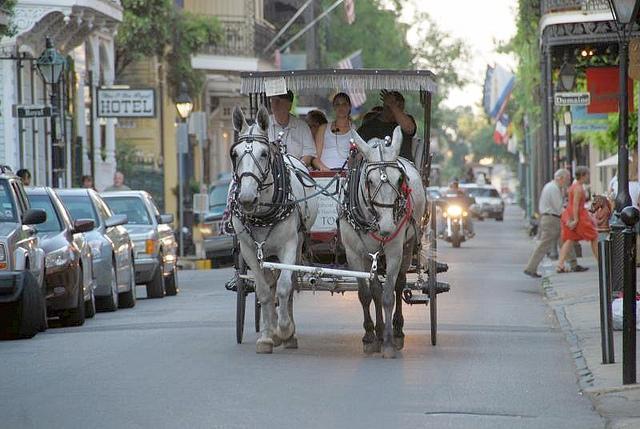Why are there horses in front of the carriage?
Select the accurate response from the four choices given to answer the question.
Options: To pull, to pet, to ride, to eat. To pull. 